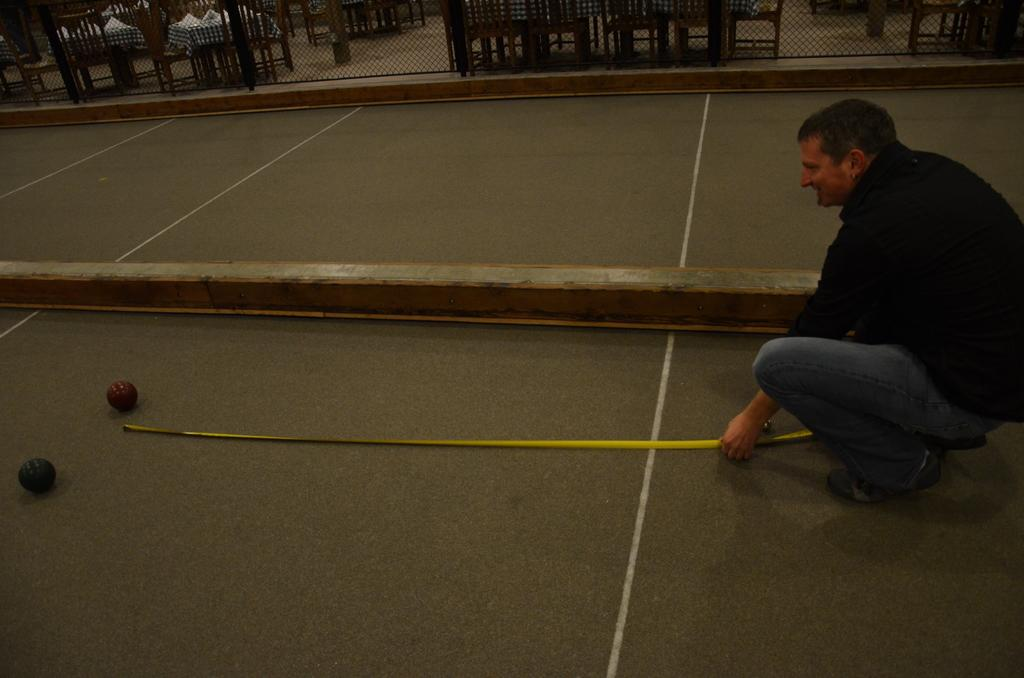What is the person in the image doing? The person is sitting on the floor and holding a stick in their hand. What is the person pointing to with the stick? The person is pointing to a ball. What can be seen in the background of the image? There are tables and a mesh in the background. How many carpenters are present in the image? There are no carpenters present in the image. What are the girls doing in the image? There are no girls present in the image. 